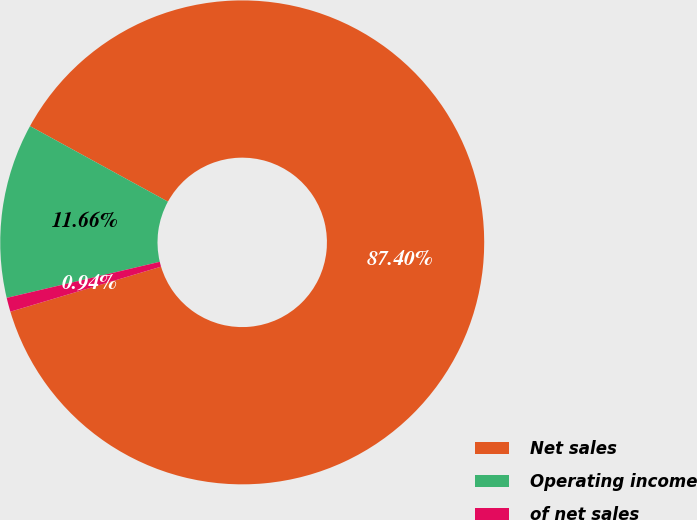Convert chart to OTSL. <chart><loc_0><loc_0><loc_500><loc_500><pie_chart><fcel>Net sales<fcel>Operating income<fcel>of net sales<nl><fcel>87.4%<fcel>11.66%<fcel>0.94%<nl></chart> 